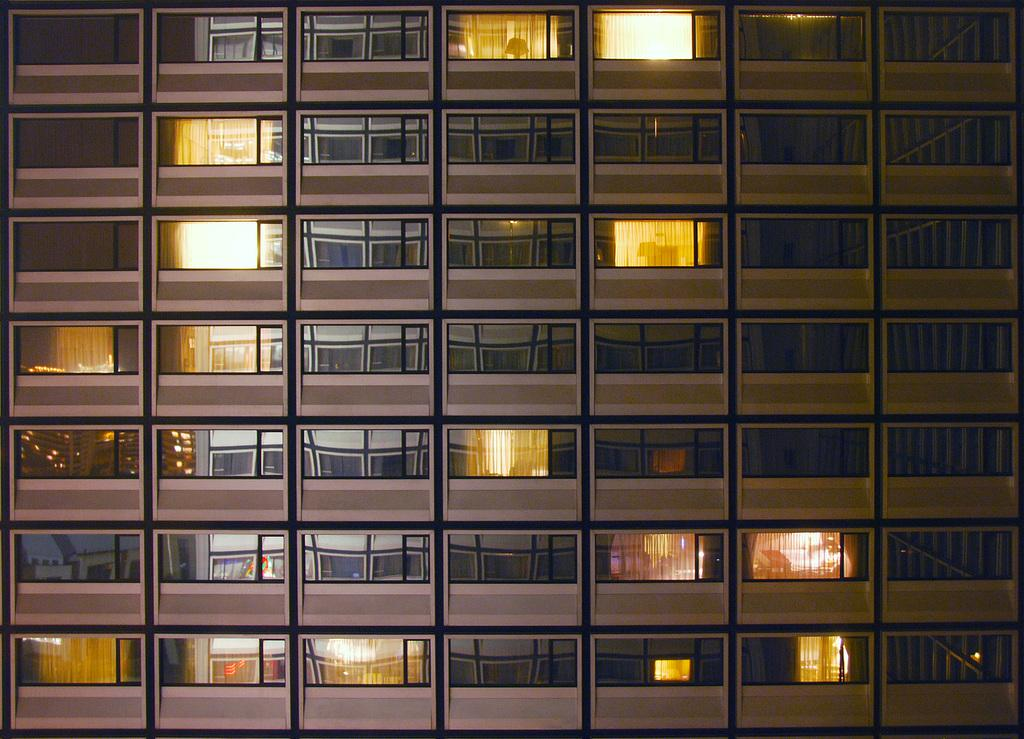What type of structure is present in the image? There is a building in the image. Can you describe the interior of the building? The building has multiple rooms. Which rooms in the building are visible in the image? Some of the rooms in the building are lightened up. Where is the faucet located in the image? There is no faucet present in the image. What type of vegetable is being prepared in the image? There is no vegetable or cooking activity present in the image. 